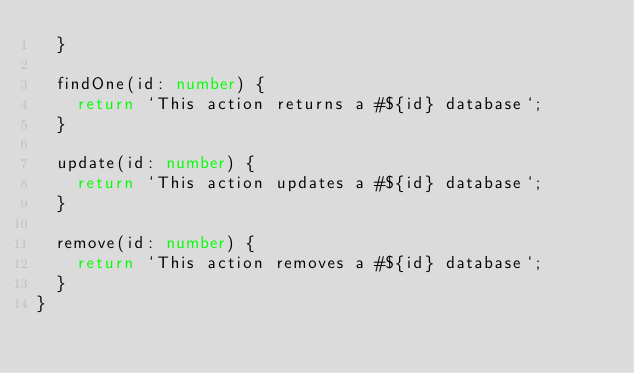Convert code to text. <code><loc_0><loc_0><loc_500><loc_500><_TypeScript_>  }

  findOne(id: number) {
    return `This action returns a #${id} database`;
  }

  update(id: number) {
    return `This action updates a #${id} database`;
  }

  remove(id: number) {
    return `This action removes a #${id} database`;
  }
}
</code> 